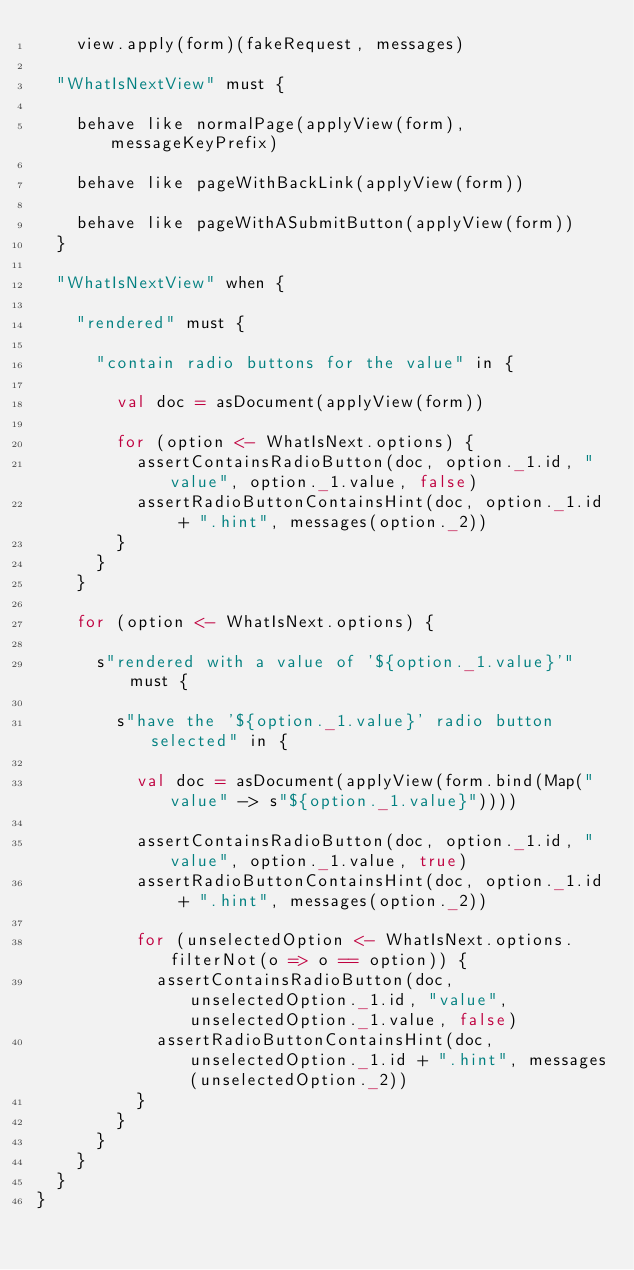Convert code to text. <code><loc_0><loc_0><loc_500><loc_500><_Scala_>    view.apply(form)(fakeRequest, messages)

  "WhatIsNextView" must {

    behave like normalPage(applyView(form), messageKeyPrefix)

    behave like pageWithBackLink(applyView(form))

    behave like pageWithASubmitButton(applyView(form))
  }

  "WhatIsNextView" when {

    "rendered" must {

      "contain radio buttons for the value" in {

        val doc = asDocument(applyView(form))

        for (option <- WhatIsNext.options) {
          assertContainsRadioButton(doc, option._1.id, "value", option._1.value, false)
          assertRadioButtonContainsHint(doc, option._1.id + ".hint", messages(option._2))
        }
      }
    }

    for (option <- WhatIsNext.options) {

      s"rendered with a value of '${option._1.value}'" must {

        s"have the '${option._1.value}' radio button selected" in {

          val doc = asDocument(applyView(form.bind(Map("value" -> s"${option._1.value}"))))

          assertContainsRadioButton(doc, option._1.id, "value", option._1.value, true)
          assertRadioButtonContainsHint(doc, option._1.id + ".hint", messages(option._2))

          for (unselectedOption <- WhatIsNext.options.filterNot(o => o == option)) {
            assertContainsRadioButton(doc, unselectedOption._1.id, "value", unselectedOption._1.value, false)
            assertRadioButtonContainsHint(doc, unselectedOption._1.id + ".hint", messages(unselectedOption._2))
          }
        }
      }
    }
  }
}
</code> 